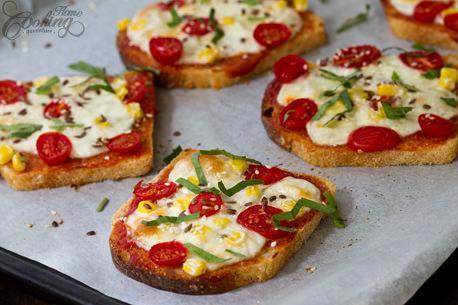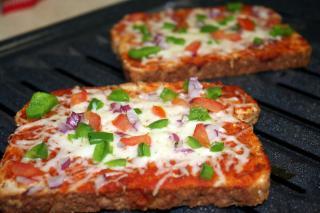The first image is the image on the left, the second image is the image on the right. Considering the images on both sides, is "One image shows four rectangles covered in red sauce, melted cheese, and green herbs on a wooden board, and the other image includes a topped slice of bread on a white plate." valid? Answer yes or no. No. The first image is the image on the left, the second image is the image on the right. Analyze the images presented: Is the assertion "In one image, four pieces of french bread pizza are covered with cheese, while a second image shows pizza made with slices of bread used for the crust." valid? Answer yes or no. No. 